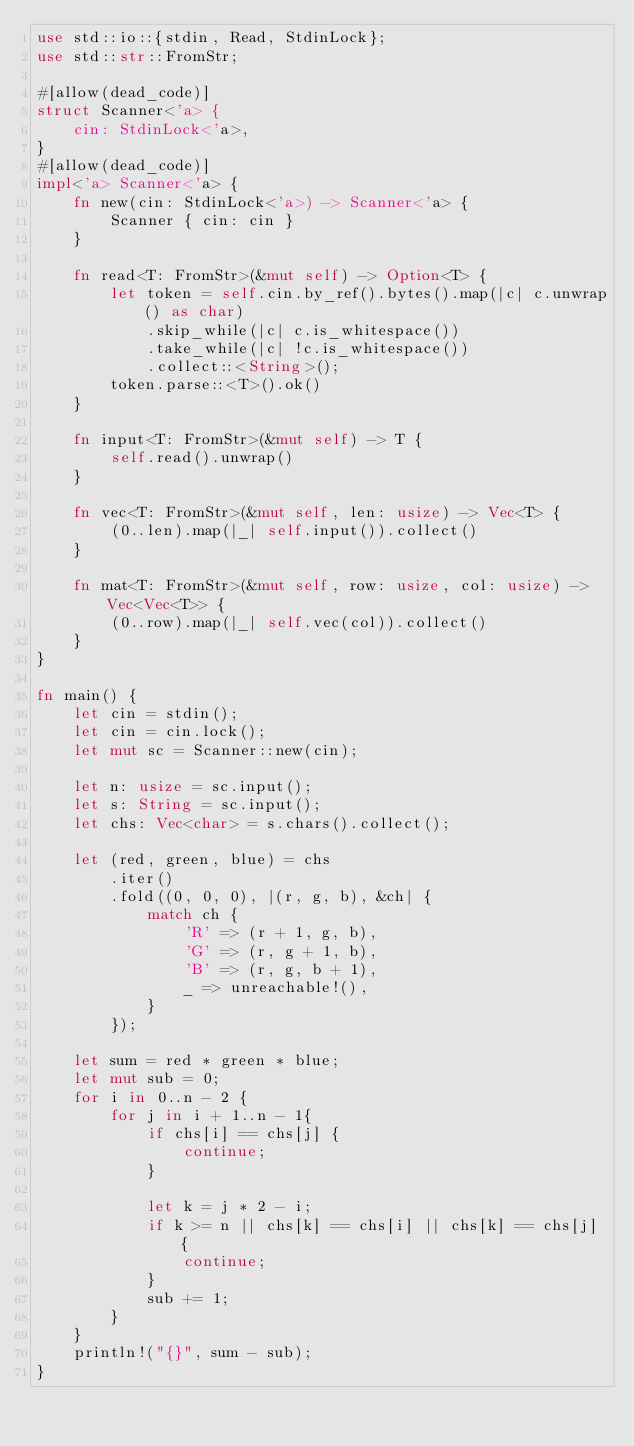Convert code to text. <code><loc_0><loc_0><loc_500><loc_500><_Rust_>use std::io::{stdin, Read, StdinLock};
use std::str::FromStr;

#[allow(dead_code)]
struct Scanner<'a> {
    cin: StdinLock<'a>,
}
#[allow(dead_code)]
impl<'a> Scanner<'a> {
    fn new(cin: StdinLock<'a>) -> Scanner<'a> {
        Scanner { cin: cin }
    }

    fn read<T: FromStr>(&mut self) -> Option<T> {
        let token = self.cin.by_ref().bytes().map(|c| c.unwrap() as char)
            .skip_while(|c| c.is_whitespace())
            .take_while(|c| !c.is_whitespace())
            .collect::<String>();
        token.parse::<T>().ok()
    }

    fn input<T: FromStr>(&mut self) -> T {
        self.read().unwrap()
    }

    fn vec<T: FromStr>(&mut self, len: usize) -> Vec<T> {
        (0..len).map(|_| self.input()).collect()
    }

    fn mat<T: FromStr>(&mut self, row: usize, col: usize) -> Vec<Vec<T>> {
        (0..row).map(|_| self.vec(col)).collect()
    }
}

fn main() {
    let cin = stdin();
    let cin = cin.lock();
    let mut sc = Scanner::new(cin);

    let n: usize = sc.input();
    let s: String = sc.input();
    let chs: Vec<char> = s.chars().collect();

    let (red, green, blue) = chs
        .iter()
        .fold((0, 0, 0), |(r, g, b), &ch| {
            match ch {
                'R' => (r + 1, g, b),
                'G' => (r, g + 1, b),
                'B' => (r, g, b + 1),
                _ => unreachable!(),
            }
        });

    let sum = red * green * blue;
    let mut sub = 0;
    for i in 0..n - 2 {
        for j in i + 1..n - 1{
            if chs[i] == chs[j] {
                continue;
            }

            let k = j * 2 - i;
            if k >= n || chs[k] == chs[i] || chs[k] == chs[j] {
                continue;
            }
            sub += 1;
        }
    }
    println!("{}", sum - sub);
}
</code> 